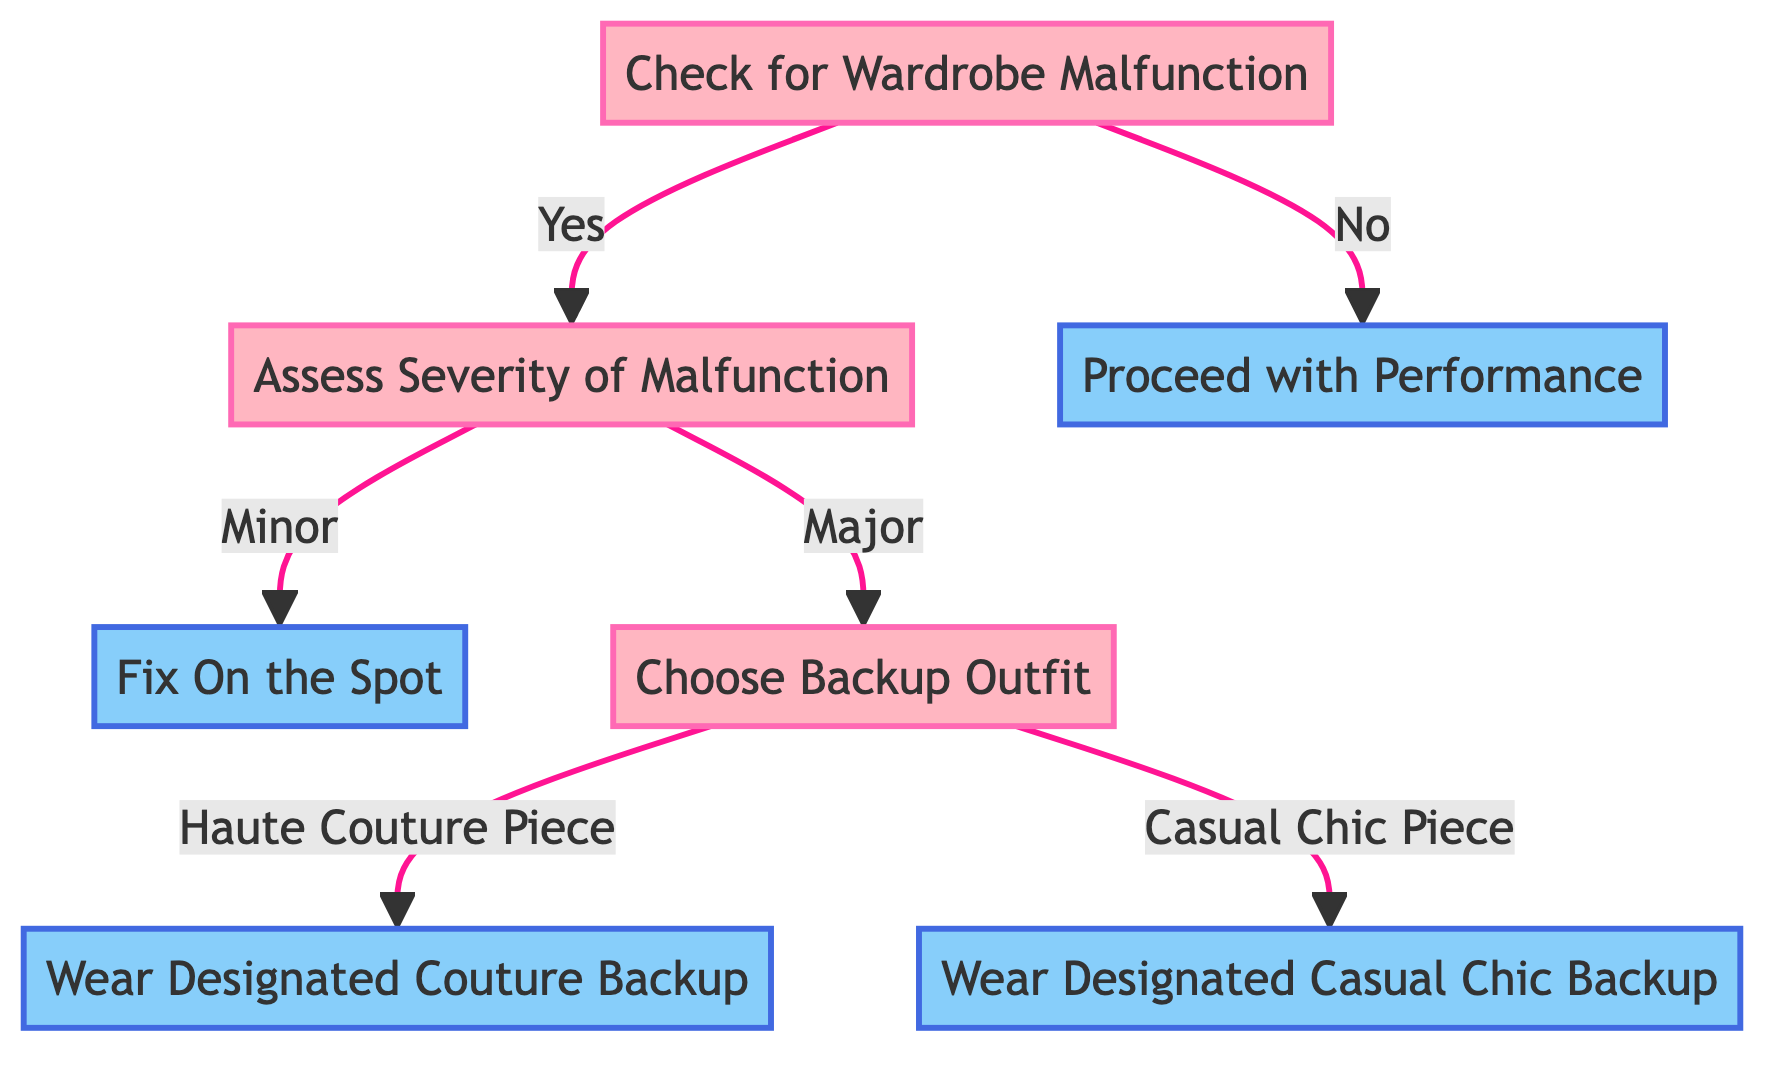What is the first decision node in the diagram? The diagram starts with the first decision node called "Check for Wardrobe Malfunction." This node asks whether there is a wardrobe malfunction or not.
Answer: Check for Wardrobe Malfunction How many actions are there in the diagram? There are four action nodes in the diagram: "Fix On the Spot," "Proceed with Performance," "Wear Designated Couture Backup," and "Wear Designated Casual Chic Backup." Each of these represents an action to take based on the decisions made.
Answer: Four What happens if there is no wardrobe malfunction? If there is no wardrobe malfunction, the flow leads directly to the action node "Proceed with Performance," indicating that the artist can continue with the current outfit without any changes.
Answer: Proceed with Performance What are the options after assessing the severity of a malfunction? After assessing the severity of a malfunction, the options are "Minor" or "Major." Each option leads to different responses to the malfunction—fixing on the spot for minor issues and choosing a backup outfit for major issues.
Answer: Minor or Major If the malfunction is major, what is the next decision? If the malfunction is major, the next decision is "Choose Backup Outfit," which determines whether to go with a Haute Couture piece or a Casual Chic piece as the backup outfit.
Answer: Choose Backup Outfit What is one method included in the "Fix On the Spot" action? One method included in the "Fix On the Spot" action is the use of an emergency sewing kit, which helps quickly address minor wardrobe malfunctions.
Answer: Use emergency sewing kit Which backup outfit option does the "Wear Designated Couture Backup" lead to? The "Wear Designated Couture Backup" leads to wearing an alternative Haute Couture piece, indicating a formal and high-end solution in response to a major malfunction.
Answer: Alternative Haute Couture piece What follows after choosing "Haute Couture Piece"? After choosing "Haute Couture Piece," the action taken is to "Wear Designated Couture Backup," which involves changing into a pre-approved alternative outfit by the designer.
Answer: Wear Designated Couture Backup 